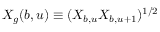<formula> <loc_0><loc_0><loc_500><loc_500>X _ { g } ( b , u ) \equiv ( X _ { b , u } X _ { b , u + 1 } ) ^ { 1 / 2 }</formula> 